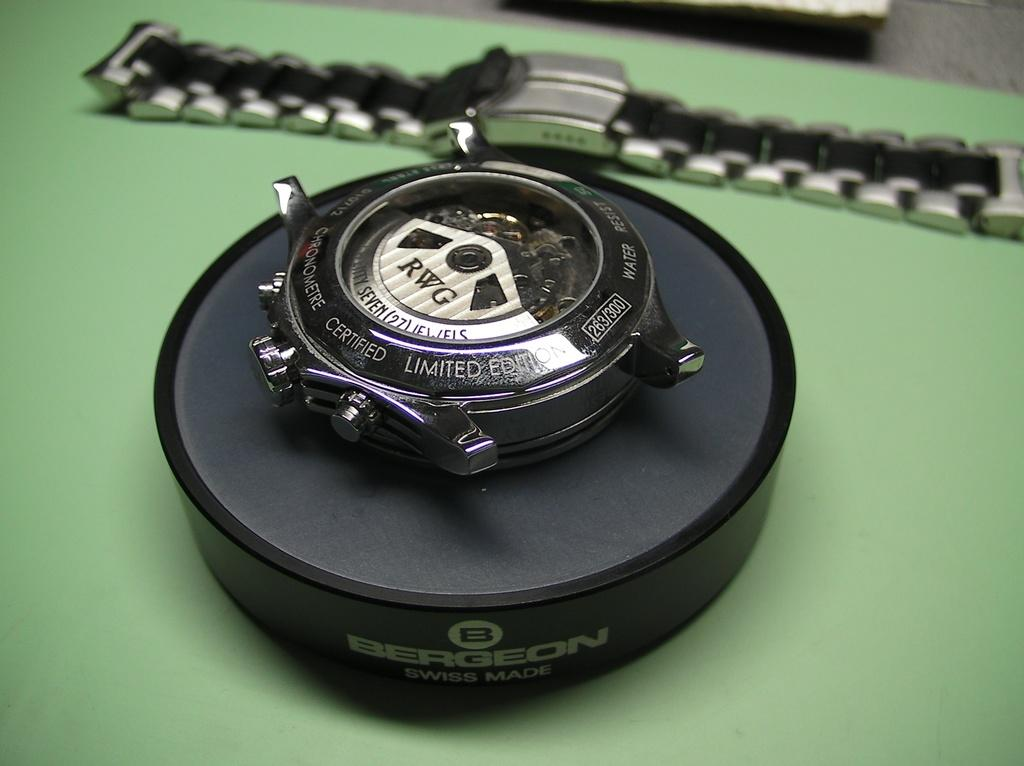Provide a one-sentence caption for the provided image. A RWG watch is pulled apart and on display. 